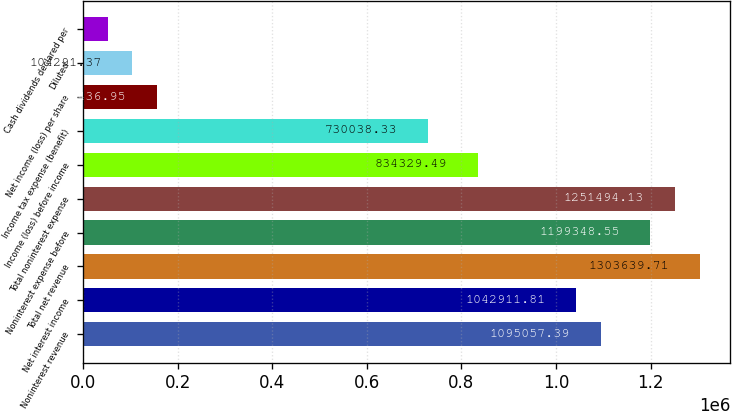Convert chart. <chart><loc_0><loc_0><loc_500><loc_500><bar_chart><fcel>Noninterest revenue<fcel>Net interest income<fcel>Total net revenue<fcel>Noninterest expense before<fcel>Total noninterest expense<fcel>Income (loss) before income<fcel>Income tax expense (benefit)<fcel>Net income (loss) per share<fcel>Diluted<fcel>Cash dividends declared per<nl><fcel>1.09506e+06<fcel>1.04291e+06<fcel>1.30364e+06<fcel>1.19935e+06<fcel>1.25149e+06<fcel>834329<fcel>730038<fcel>156437<fcel>104291<fcel>52145.8<nl></chart> 